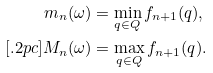Convert formula to latex. <formula><loc_0><loc_0><loc_500><loc_500>m _ { n } ( \omega ) & = \min _ { q \in Q } f _ { n + 1 } ( q ) , \\ [ . 2 p c ] M _ { n } ( \omega ) & = \max _ { q \in Q } f _ { n + 1 } ( q ) .</formula> 